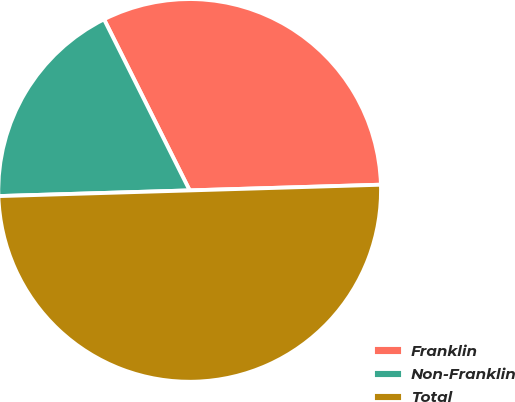<chart> <loc_0><loc_0><loc_500><loc_500><pie_chart><fcel>Franklin<fcel>Non-Franklin<fcel>Total<nl><fcel>31.91%<fcel>18.09%<fcel>50.0%<nl></chart> 